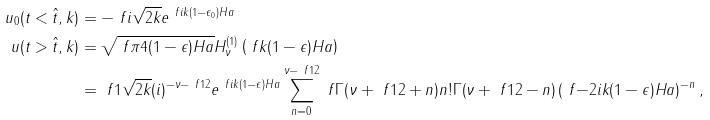<formula> <loc_0><loc_0><loc_500><loc_500>u _ { 0 } ( t < \hat { t } , k ) & = - \ f { i } { \sqrt { 2 k } } e ^ { \ f { i k } { ( 1 - \epsilon _ { 0 } ) H a } } \\ u ( t > \hat { t } , k ) & = \sqrt { \ f { \pi } { 4 ( 1 - \epsilon ) H a } } H ^ { ( 1 ) } _ { \nu } \left ( \ f { k } { ( 1 - \epsilon ) H a } \right ) \\ & = \ f { 1 } { \sqrt { 2 k } } ( i ) ^ { - \nu - \ f { 1 } { 2 } } e ^ { \ f { i k } { ( 1 - \epsilon ) H a } } \sum _ { n = 0 } ^ { \nu - \ f { 1 } { 2 } } \ f { \Gamma ( \nu + \ f { 1 } { 2 } + n ) } { n ! \Gamma ( \nu + \ f { 1 } { 2 } - n ) } \left ( \ f { - 2 i k } { ( 1 - \epsilon ) H a } \right ) ^ { - n } ,</formula> 